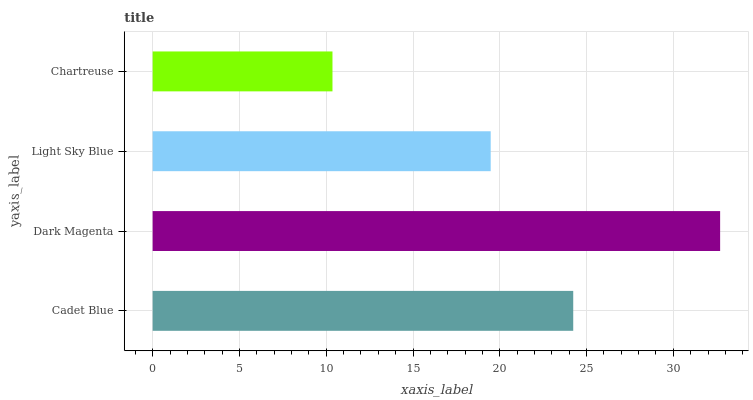Is Chartreuse the minimum?
Answer yes or no. Yes. Is Dark Magenta the maximum?
Answer yes or no. Yes. Is Light Sky Blue the minimum?
Answer yes or no. No. Is Light Sky Blue the maximum?
Answer yes or no. No. Is Dark Magenta greater than Light Sky Blue?
Answer yes or no. Yes. Is Light Sky Blue less than Dark Magenta?
Answer yes or no. Yes. Is Light Sky Blue greater than Dark Magenta?
Answer yes or no. No. Is Dark Magenta less than Light Sky Blue?
Answer yes or no. No. Is Cadet Blue the high median?
Answer yes or no. Yes. Is Light Sky Blue the low median?
Answer yes or no. Yes. Is Chartreuse the high median?
Answer yes or no. No. Is Chartreuse the low median?
Answer yes or no. No. 